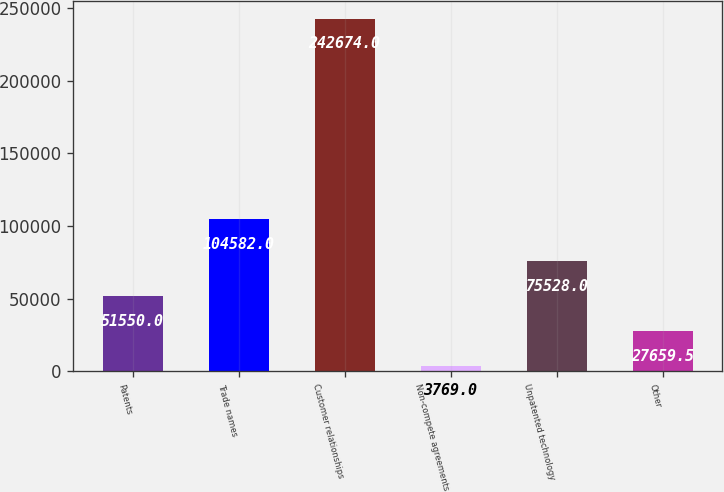Convert chart to OTSL. <chart><loc_0><loc_0><loc_500><loc_500><bar_chart><fcel>Patents<fcel>Trade names<fcel>Customer relationships<fcel>Non-compete agreements<fcel>Unpatented technology<fcel>Other<nl><fcel>51550<fcel>104582<fcel>242674<fcel>3769<fcel>75528<fcel>27659.5<nl></chart> 